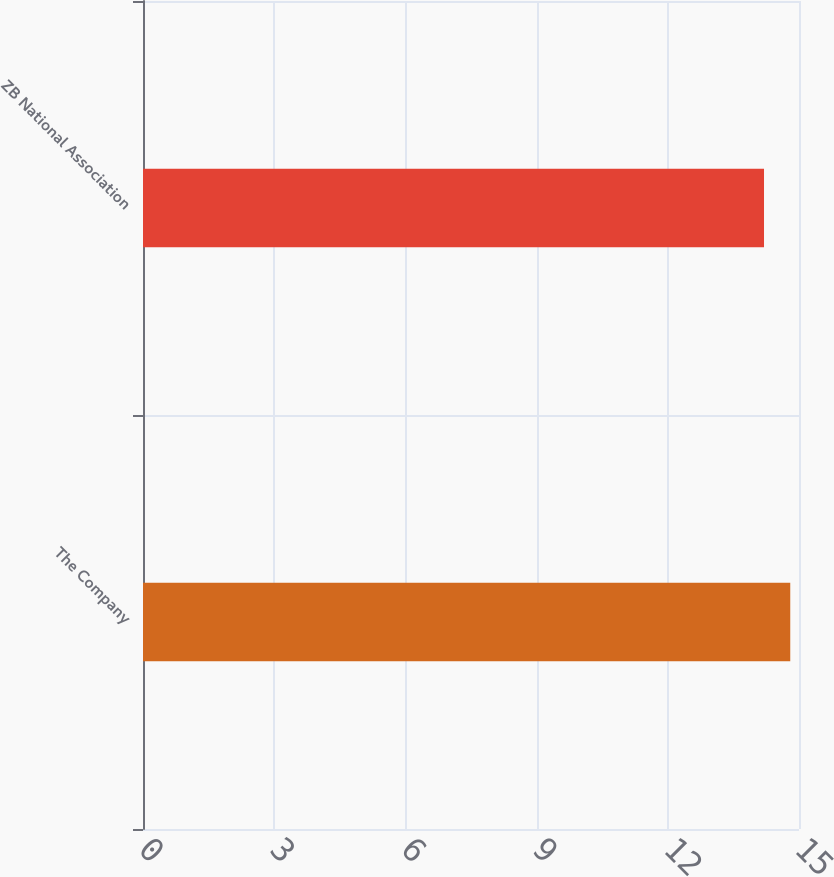<chart> <loc_0><loc_0><loc_500><loc_500><bar_chart><fcel>The Company<fcel>ZB National Association<nl><fcel>14.8<fcel>14.2<nl></chart> 